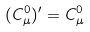<formula> <loc_0><loc_0><loc_500><loc_500>( { C } ^ { 0 } _ { \mu } ) ^ { \prime } = C _ { \mu } ^ { 0 }</formula> 